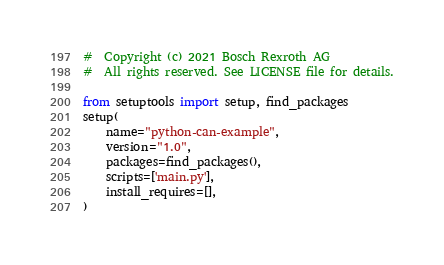Convert code to text. <code><loc_0><loc_0><loc_500><loc_500><_Python_>#  Copyright (c) 2021 Bosch Rexroth AG
#  All rights reserved. See LICENSE file for details.

from setuptools import setup, find_packages
setup(
    name="python-can-example",
    version="1.0",
    packages=find_packages(),
    scripts=['main.py'],
    install_requires=[],
)
</code> 